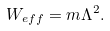Convert formula to latex. <formula><loc_0><loc_0><loc_500><loc_500>W _ { e f f } = m \Lambda ^ { 2 } .</formula> 